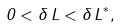Convert formula to latex. <formula><loc_0><loc_0><loc_500><loc_500>0 < \delta \, L < { \delta \, L } ^ { * } ,</formula> 